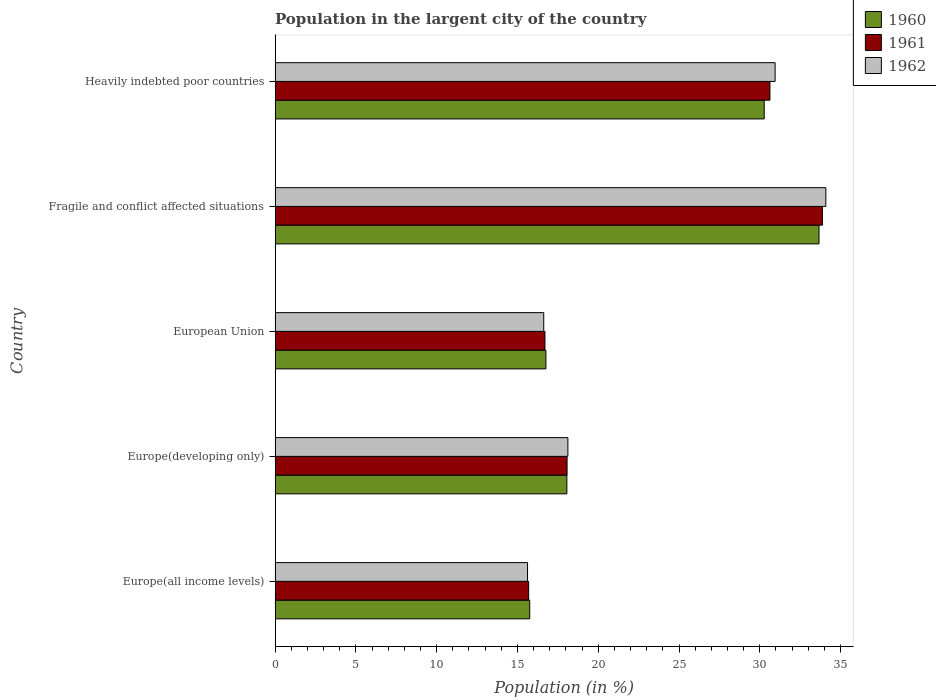How many different coloured bars are there?
Your answer should be very brief. 3. Are the number of bars per tick equal to the number of legend labels?
Provide a short and direct response. Yes. Are the number of bars on each tick of the Y-axis equal?
Offer a very short reply. Yes. How many bars are there on the 3rd tick from the bottom?
Provide a succinct answer. 3. What is the label of the 3rd group of bars from the top?
Provide a succinct answer. European Union. What is the percentage of population in the largent city in 1961 in Fragile and conflict affected situations?
Ensure brevity in your answer.  33.88. Across all countries, what is the maximum percentage of population in the largent city in 1960?
Your answer should be very brief. 33.66. Across all countries, what is the minimum percentage of population in the largent city in 1961?
Your response must be concise. 15.69. In which country was the percentage of population in the largent city in 1962 maximum?
Ensure brevity in your answer.  Fragile and conflict affected situations. In which country was the percentage of population in the largent city in 1962 minimum?
Your response must be concise. Europe(all income levels). What is the total percentage of population in the largent city in 1961 in the graph?
Your response must be concise. 114.97. What is the difference between the percentage of population in the largent city in 1960 in Europe(all income levels) and that in Fragile and conflict affected situations?
Offer a very short reply. -17.91. What is the difference between the percentage of population in the largent city in 1960 in Heavily indebted poor countries and the percentage of population in the largent city in 1961 in European Union?
Provide a short and direct response. 13.57. What is the average percentage of population in the largent city in 1961 per country?
Your response must be concise. 22.99. What is the difference between the percentage of population in the largent city in 1960 and percentage of population in the largent city in 1962 in Europe(all income levels)?
Your response must be concise. 0.13. What is the ratio of the percentage of population in the largent city in 1962 in Europe(all income levels) to that in European Union?
Your response must be concise. 0.94. What is the difference between the highest and the second highest percentage of population in the largent city in 1961?
Ensure brevity in your answer.  3.25. What is the difference between the highest and the lowest percentage of population in the largent city in 1961?
Provide a short and direct response. 18.18. How many bars are there?
Give a very brief answer. 15. How many countries are there in the graph?
Offer a very short reply. 5. Does the graph contain any zero values?
Keep it short and to the point. No. What is the title of the graph?
Provide a short and direct response. Population in the largent city of the country. Does "1989" appear as one of the legend labels in the graph?
Your answer should be very brief. No. What is the label or title of the X-axis?
Offer a terse response. Population (in %). What is the Population (in %) of 1960 in Europe(all income levels)?
Your answer should be compact. 15.76. What is the Population (in %) in 1961 in Europe(all income levels)?
Offer a terse response. 15.69. What is the Population (in %) of 1962 in Europe(all income levels)?
Keep it short and to the point. 15.62. What is the Population (in %) in 1960 in Europe(developing only)?
Your answer should be very brief. 18.06. What is the Population (in %) of 1961 in Europe(developing only)?
Your answer should be very brief. 18.07. What is the Population (in %) of 1962 in Europe(developing only)?
Your answer should be very brief. 18.12. What is the Population (in %) of 1960 in European Union?
Ensure brevity in your answer.  16.76. What is the Population (in %) of 1961 in European Union?
Offer a very short reply. 16.7. What is the Population (in %) of 1962 in European Union?
Offer a very short reply. 16.63. What is the Population (in %) in 1960 in Fragile and conflict affected situations?
Make the answer very short. 33.66. What is the Population (in %) of 1961 in Fragile and conflict affected situations?
Provide a succinct answer. 33.88. What is the Population (in %) in 1962 in Fragile and conflict affected situations?
Your response must be concise. 34.09. What is the Population (in %) in 1960 in Heavily indebted poor countries?
Provide a succinct answer. 30.27. What is the Population (in %) of 1961 in Heavily indebted poor countries?
Your answer should be very brief. 30.63. What is the Population (in %) of 1962 in Heavily indebted poor countries?
Your response must be concise. 30.95. Across all countries, what is the maximum Population (in %) of 1960?
Provide a short and direct response. 33.66. Across all countries, what is the maximum Population (in %) of 1961?
Give a very brief answer. 33.88. Across all countries, what is the maximum Population (in %) in 1962?
Ensure brevity in your answer.  34.09. Across all countries, what is the minimum Population (in %) in 1960?
Provide a succinct answer. 15.76. Across all countries, what is the minimum Population (in %) of 1961?
Provide a succinct answer. 15.69. Across all countries, what is the minimum Population (in %) in 1962?
Provide a short and direct response. 15.62. What is the total Population (in %) of 1960 in the graph?
Your answer should be compact. 114.52. What is the total Population (in %) in 1961 in the graph?
Ensure brevity in your answer.  114.97. What is the total Population (in %) of 1962 in the graph?
Your response must be concise. 115.41. What is the difference between the Population (in %) of 1960 in Europe(all income levels) and that in Europe(developing only)?
Ensure brevity in your answer.  -2.3. What is the difference between the Population (in %) of 1961 in Europe(all income levels) and that in Europe(developing only)?
Your response must be concise. -2.38. What is the difference between the Population (in %) in 1962 in Europe(all income levels) and that in Europe(developing only)?
Keep it short and to the point. -2.5. What is the difference between the Population (in %) in 1960 in Europe(all income levels) and that in European Union?
Ensure brevity in your answer.  -1. What is the difference between the Population (in %) of 1961 in Europe(all income levels) and that in European Union?
Provide a short and direct response. -1.01. What is the difference between the Population (in %) of 1962 in Europe(all income levels) and that in European Union?
Your answer should be compact. -1. What is the difference between the Population (in %) of 1960 in Europe(all income levels) and that in Fragile and conflict affected situations?
Offer a terse response. -17.91. What is the difference between the Population (in %) of 1961 in Europe(all income levels) and that in Fragile and conflict affected situations?
Your response must be concise. -18.18. What is the difference between the Population (in %) in 1962 in Europe(all income levels) and that in Fragile and conflict affected situations?
Provide a succinct answer. -18.46. What is the difference between the Population (in %) in 1960 in Europe(all income levels) and that in Heavily indebted poor countries?
Keep it short and to the point. -14.51. What is the difference between the Population (in %) in 1961 in Europe(all income levels) and that in Heavily indebted poor countries?
Provide a short and direct response. -14.93. What is the difference between the Population (in %) in 1962 in Europe(all income levels) and that in Heavily indebted poor countries?
Give a very brief answer. -15.32. What is the difference between the Population (in %) of 1960 in Europe(developing only) and that in European Union?
Give a very brief answer. 1.3. What is the difference between the Population (in %) of 1961 in Europe(developing only) and that in European Union?
Offer a very short reply. 1.37. What is the difference between the Population (in %) of 1962 in Europe(developing only) and that in European Union?
Offer a terse response. 1.5. What is the difference between the Population (in %) in 1960 in Europe(developing only) and that in Fragile and conflict affected situations?
Keep it short and to the point. -15.6. What is the difference between the Population (in %) in 1961 in Europe(developing only) and that in Fragile and conflict affected situations?
Your response must be concise. -15.81. What is the difference between the Population (in %) of 1962 in Europe(developing only) and that in Fragile and conflict affected situations?
Keep it short and to the point. -15.96. What is the difference between the Population (in %) in 1960 in Europe(developing only) and that in Heavily indebted poor countries?
Keep it short and to the point. -12.21. What is the difference between the Population (in %) of 1961 in Europe(developing only) and that in Heavily indebted poor countries?
Offer a terse response. -12.56. What is the difference between the Population (in %) in 1962 in Europe(developing only) and that in Heavily indebted poor countries?
Offer a very short reply. -12.82. What is the difference between the Population (in %) of 1960 in European Union and that in Fragile and conflict affected situations?
Provide a succinct answer. -16.9. What is the difference between the Population (in %) of 1961 in European Union and that in Fragile and conflict affected situations?
Your answer should be compact. -17.17. What is the difference between the Population (in %) of 1962 in European Union and that in Fragile and conflict affected situations?
Make the answer very short. -17.46. What is the difference between the Population (in %) of 1960 in European Union and that in Heavily indebted poor countries?
Offer a very short reply. -13.51. What is the difference between the Population (in %) of 1961 in European Union and that in Heavily indebted poor countries?
Your response must be concise. -13.92. What is the difference between the Population (in %) in 1962 in European Union and that in Heavily indebted poor countries?
Make the answer very short. -14.32. What is the difference between the Population (in %) of 1960 in Fragile and conflict affected situations and that in Heavily indebted poor countries?
Your response must be concise. 3.39. What is the difference between the Population (in %) of 1961 in Fragile and conflict affected situations and that in Heavily indebted poor countries?
Provide a succinct answer. 3.25. What is the difference between the Population (in %) in 1962 in Fragile and conflict affected situations and that in Heavily indebted poor countries?
Offer a very short reply. 3.14. What is the difference between the Population (in %) in 1960 in Europe(all income levels) and the Population (in %) in 1961 in Europe(developing only)?
Offer a terse response. -2.31. What is the difference between the Population (in %) of 1960 in Europe(all income levels) and the Population (in %) of 1962 in Europe(developing only)?
Your answer should be compact. -2.36. What is the difference between the Population (in %) of 1961 in Europe(all income levels) and the Population (in %) of 1962 in Europe(developing only)?
Give a very brief answer. -2.43. What is the difference between the Population (in %) in 1960 in Europe(all income levels) and the Population (in %) in 1961 in European Union?
Offer a terse response. -0.94. What is the difference between the Population (in %) in 1960 in Europe(all income levels) and the Population (in %) in 1962 in European Union?
Your answer should be compact. -0.87. What is the difference between the Population (in %) of 1961 in Europe(all income levels) and the Population (in %) of 1962 in European Union?
Give a very brief answer. -0.93. What is the difference between the Population (in %) of 1960 in Europe(all income levels) and the Population (in %) of 1961 in Fragile and conflict affected situations?
Make the answer very short. -18.12. What is the difference between the Population (in %) in 1960 in Europe(all income levels) and the Population (in %) in 1962 in Fragile and conflict affected situations?
Provide a short and direct response. -18.33. What is the difference between the Population (in %) in 1961 in Europe(all income levels) and the Population (in %) in 1962 in Fragile and conflict affected situations?
Give a very brief answer. -18.39. What is the difference between the Population (in %) of 1960 in Europe(all income levels) and the Population (in %) of 1961 in Heavily indebted poor countries?
Ensure brevity in your answer.  -14.87. What is the difference between the Population (in %) of 1960 in Europe(all income levels) and the Population (in %) of 1962 in Heavily indebted poor countries?
Your answer should be compact. -15.19. What is the difference between the Population (in %) of 1961 in Europe(all income levels) and the Population (in %) of 1962 in Heavily indebted poor countries?
Give a very brief answer. -15.25. What is the difference between the Population (in %) in 1960 in Europe(developing only) and the Population (in %) in 1961 in European Union?
Ensure brevity in your answer.  1.36. What is the difference between the Population (in %) in 1960 in Europe(developing only) and the Population (in %) in 1962 in European Union?
Keep it short and to the point. 1.43. What is the difference between the Population (in %) of 1961 in Europe(developing only) and the Population (in %) of 1962 in European Union?
Your response must be concise. 1.44. What is the difference between the Population (in %) in 1960 in Europe(developing only) and the Population (in %) in 1961 in Fragile and conflict affected situations?
Ensure brevity in your answer.  -15.82. What is the difference between the Population (in %) of 1960 in Europe(developing only) and the Population (in %) of 1962 in Fragile and conflict affected situations?
Ensure brevity in your answer.  -16.03. What is the difference between the Population (in %) in 1961 in Europe(developing only) and the Population (in %) in 1962 in Fragile and conflict affected situations?
Provide a succinct answer. -16.02. What is the difference between the Population (in %) in 1960 in Europe(developing only) and the Population (in %) in 1961 in Heavily indebted poor countries?
Offer a terse response. -12.57. What is the difference between the Population (in %) of 1960 in Europe(developing only) and the Population (in %) of 1962 in Heavily indebted poor countries?
Make the answer very short. -12.89. What is the difference between the Population (in %) in 1961 in Europe(developing only) and the Population (in %) in 1962 in Heavily indebted poor countries?
Give a very brief answer. -12.88. What is the difference between the Population (in %) in 1960 in European Union and the Population (in %) in 1961 in Fragile and conflict affected situations?
Offer a very short reply. -17.12. What is the difference between the Population (in %) in 1960 in European Union and the Population (in %) in 1962 in Fragile and conflict affected situations?
Provide a succinct answer. -17.33. What is the difference between the Population (in %) of 1961 in European Union and the Population (in %) of 1962 in Fragile and conflict affected situations?
Offer a terse response. -17.38. What is the difference between the Population (in %) in 1960 in European Union and the Population (in %) in 1961 in Heavily indebted poor countries?
Offer a very short reply. -13.87. What is the difference between the Population (in %) in 1960 in European Union and the Population (in %) in 1962 in Heavily indebted poor countries?
Your answer should be compact. -14.19. What is the difference between the Population (in %) in 1961 in European Union and the Population (in %) in 1962 in Heavily indebted poor countries?
Ensure brevity in your answer.  -14.24. What is the difference between the Population (in %) of 1960 in Fragile and conflict affected situations and the Population (in %) of 1961 in Heavily indebted poor countries?
Make the answer very short. 3.04. What is the difference between the Population (in %) of 1960 in Fragile and conflict affected situations and the Population (in %) of 1962 in Heavily indebted poor countries?
Offer a terse response. 2.72. What is the difference between the Population (in %) in 1961 in Fragile and conflict affected situations and the Population (in %) in 1962 in Heavily indebted poor countries?
Give a very brief answer. 2.93. What is the average Population (in %) of 1960 per country?
Your answer should be very brief. 22.9. What is the average Population (in %) in 1961 per country?
Offer a very short reply. 22.99. What is the average Population (in %) of 1962 per country?
Your answer should be compact. 23.08. What is the difference between the Population (in %) in 1960 and Population (in %) in 1961 in Europe(all income levels)?
Offer a very short reply. 0.06. What is the difference between the Population (in %) of 1960 and Population (in %) of 1962 in Europe(all income levels)?
Offer a very short reply. 0.14. What is the difference between the Population (in %) in 1961 and Population (in %) in 1962 in Europe(all income levels)?
Make the answer very short. 0.07. What is the difference between the Population (in %) in 1960 and Population (in %) in 1961 in Europe(developing only)?
Make the answer very short. -0.01. What is the difference between the Population (in %) of 1960 and Population (in %) of 1962 in Europe(developing only)?
Ensure brevity in your answer.  -0.06. What is the difference between the Population (in %) of 1961 and Population (in %) of 1962 in Europe(developing only)?
Make the answer very short. -0.05. What is the difference between the Population (in %) in 1960 and Population (in %) in 1961 in European Union?
Your answer should be very brief. 0.06. What is the difference between the Population (in %) of 1960 and Population (in %) of 1962 in European Union?
Your answer should be very brief. 0.13. What is the difference between the Population (in %) of 1961 and Population (in %) of 1962 in European Union?
Offer a very short reply. 0.08. What is the difference between the Population (in %) of 1960 and Population (in %) of 1961 in Fragile and conflict affected situations?
Keep it short and to the point. -0.21. What is the difference between the Population (in %) in 1960 and Population (in %) in 1962 in Fragile and conflict affected situations?
Your response must be concise. -0.42. What is the difference between the Population (in %) of 1961 and Population (in %) of 1962 in Fragile and conflict affected situations?
Ensure brevity in your answer.  -0.21. What is the difference between the Population (in %) of 1960 and Population (in %) of 1961 in Heavily indebted poor countries?
Give a very brief answer. -0.35. What is the difference between the Population (in %) of 1960 and Population (in %) of 1962 in Heavily indebted poor countries?
Offer a very short reply. -0.67. What is the difference between the Population (in %) of 1961 and Population (in %) of 1962 in Heavily indebted poor countries?
Keep it short and to the point. -0.32. What is the ratio of the Population (in %) in 1960 in Europe(all income levels) to that in Europe(developing only)?
Provide a succinct answer. 0.87. What is the ratio of the Population (in %) of 1961 in Europe(all income levels) to that in Europe(developing only)?
Provide a succinct answer. 0.87. What is the ratio of the Population (in %) in 1962 in Europe(all income levels) to that in Europe(developing only)?
Offer a very short reply. 0.86. What is the ratio of the Population (in %) in 1960 in Europe(all income levels) to that in European Union?
Make the answer very short. 0.94. What is the ratio of the Population (in %) in 1961 in Europe(all income levels) to that in European Union?
Your response must be concise. 0.94. What is the ratio of the Population (in %) in 1962 in Europe(all income levels) to that in European Union?
Keep it short and to the point. 0.94. What is the ratio of the Population (in %) in 1960 in Europe(all income levels) to that in Fragile and conflict affected situations?
Provide a short and direct response. 0.47. What is the ratio of the Population (in %) in 1961 in Europe(all income levels) to that in Fragile and conflict affected situations?
Offer a terse response. 0.46. What is the ratio of the Population (in %) in 1962 in Europe(all income levels) to that in Fragile and conflict affected situations?
Offer a very short reply. 0.46. What is the ratio of the Population (in %) of 1960 in Europe(all income levels) to that in Heavily indebted poor countries?
Ensure brevity in your answer.  0.52. What is the ratio of the Population (in %) in 1961 in Europe(all income levels) to that in Heavily indebted poor countries?
Provide a short and direct response. 0.51. What is the ratio of the Population (in %) in 1962 in Europe(all income levels) to that in Heavily indebted poor countries?
Give a very brief answer. 0.5. What is the ratio of the Population (in %) of 1960 in Europe(developing only) to that in European Union?
Ensure brevity in your answer.  1.08. What is the ratio of the Population (in %) in 1961 in Europe(developing only) to that in European Union?
Ensure brevity in your answer.  1.08. What is the ratio of the Population (in %) in 1962 in Europe(developing only) to that in European Union?
Provide a succinct answer. 1.09. What is the ratio of the Population (in %) in 1960 in Europe(developing only) to that in Fragile and conflict affected situations?
Your answer should be very brief. 0.54. What is the ratio of the Population (in %) of 1961 in Europe(developing only) to that in Fragile and conflict affected situations?
Offer a very short reply. 0.53. What is the ratio of the Population (in %) of 1962 in Europe(developing only) to that in Fragile and conflict affected situations?
Your response must be concise. 0.53. What is the ratio of the Population (in %) of 1960 in Europe(developing only) to that in Heavily indebted poor countries?
Give a very brief answer. 0.6. What is the ratio of the Population (in %) in 1961 in Europe(developing only) to that in Heavily indebted poor countries?
Give a very brief answer. 0.59. What is the ratio of the Population (in %) in 1962 in Europe(developing only) to that in Heavily indebted poor countries?
Make the answer very short. 0.59. What is the ratio of the Population (in %) in 1960 in European Union to that in Fragile and conflict affected situations?
Your answer should be compact. 0.5. What is the ratio of the Population (in %) in 1961 in European Union to that in Fragile and conflict affected situations?
Your answer should be compact. 0.49. What is the ratio of the Population (in %) in 1962 in European Union to that in Fragile and conflict affected situations?
Make the answer very short. 0.49. What is the ratio of the Population (in %) in 1960 in European Union to that in Heavily indebted poor countries?
Provide a succinct answer. 0.55. What is the ratio of the Population (in %) in 1961 in European Union to that in Heavily indebted poor countries?
Give a very brief answer. 0.55. What is the ratio of the Population (in %) of 1962 in European Union to that in Heavily indebted poor countries?
Give a very brief answer. 0.54. What is the ratio of the Population (in %) of 1960 in Fragile and conflict affected situations to that in Heavily indebted poor countries?
Make the answer very short. 1.11. What is the ratio of the Population (in %) of 1961 in Fragile and conflict affected situations to that in Heavily indebted poor countries?
Ensure brevity in your answer.  1.11. What is the ratio of the Population (in %) in 1962 in Fragile and conflict affected situations to that in Heavily indebted poor countries?
Offer a very short reply. 1.1. What is the difference between the highest and the second highest Population (in %) in 1960?
Provide a short and direct response. 3.39. What is the difference between the highest and the second highest Population (in %) of 1961?
Give a very brief answer. 3.25. What is the difference between the highest and the second highest Population (in %) of 1962?
Keep it short and to the point. 3.14. What is the difference between the highest and the lowest Population (in %) in 1960?
Ensure brevity in your answer.  17.91. What is the difference between the highest and the lowest Population (in %) of 1961?
Your answer should be compact. 18.18. What is the difference between the highest and the lowest Population (in %) in 1962?
Offer a terse response. 18.46. 